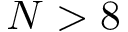Convert formula to latex. <formula><loc_0><loc_0><loc_500><loc_500>N > 8</formula> 